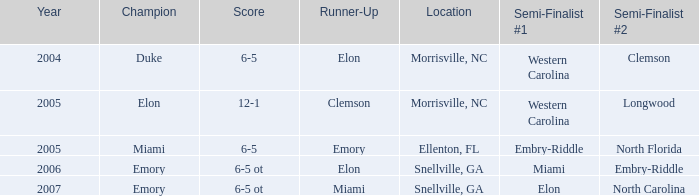Who were all the runners-up when embry-riddle reached the first semi-finalist position? Emory. 